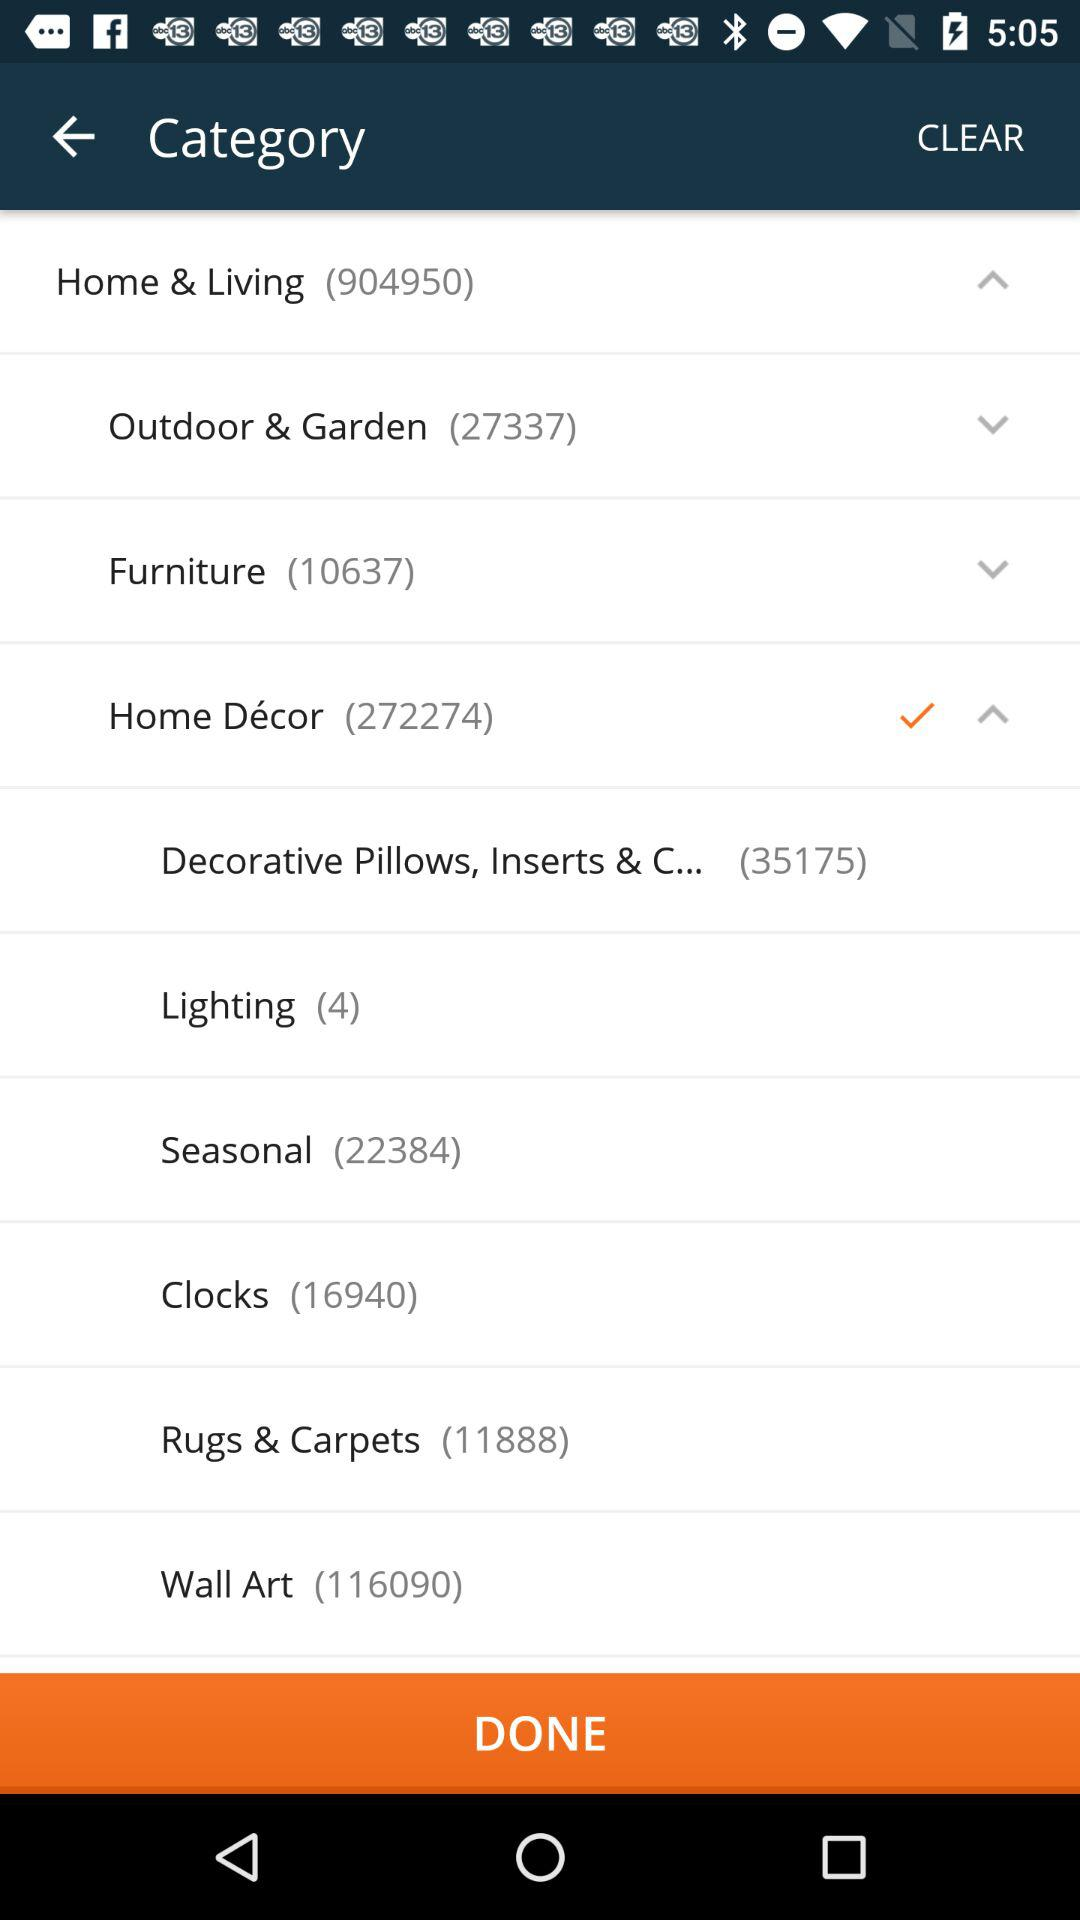How many results are shown for furniture? The result shown for furniture is 10637. 